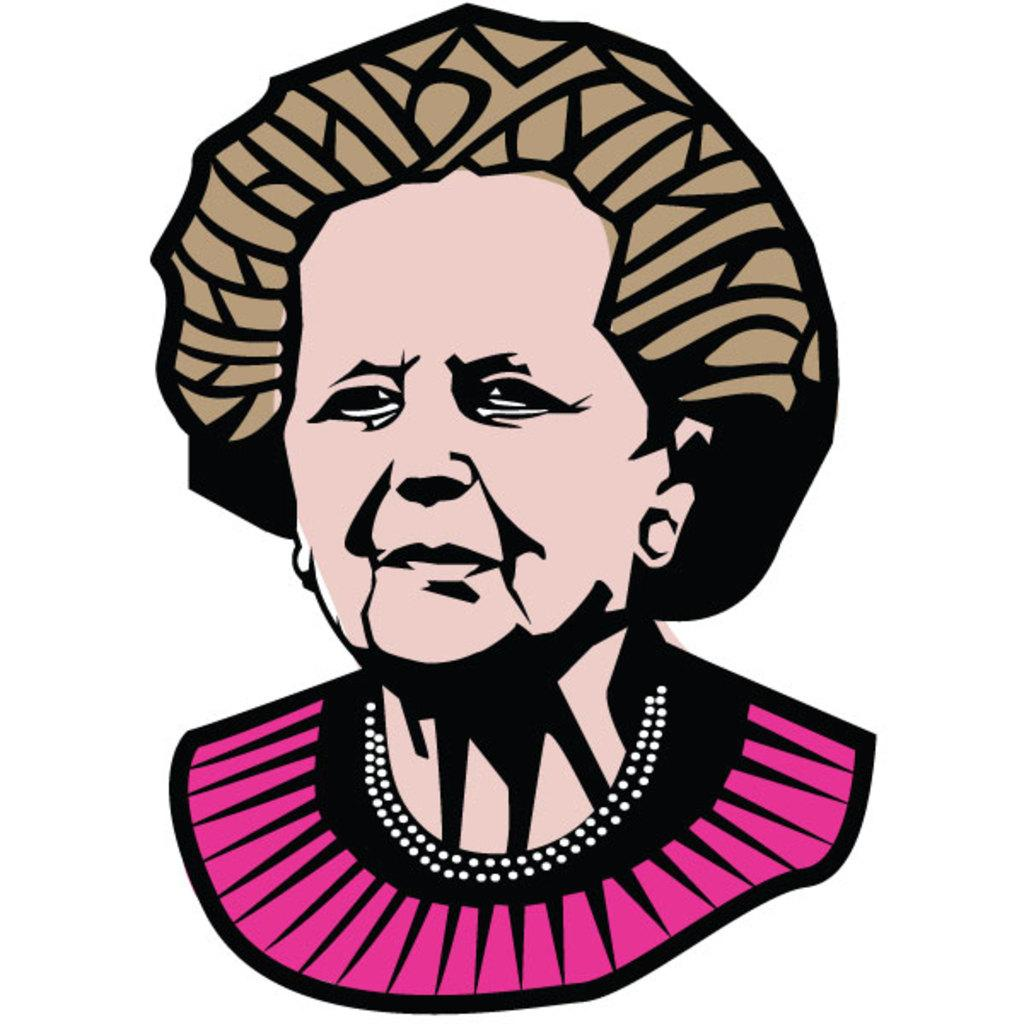What is the main subject of the image? The main subject of the image is a graphic art or illustration of a woman. What is the woman wearing in the image? The woman is wearing a pink and black dress in the image. What color is the background of the image? The background of the image is white in color. What type of wood is used to create the woman's dress in the image? There is no wood present in the image, as it is a graphic art or illustration of a woman wearing a pink and black dress. 